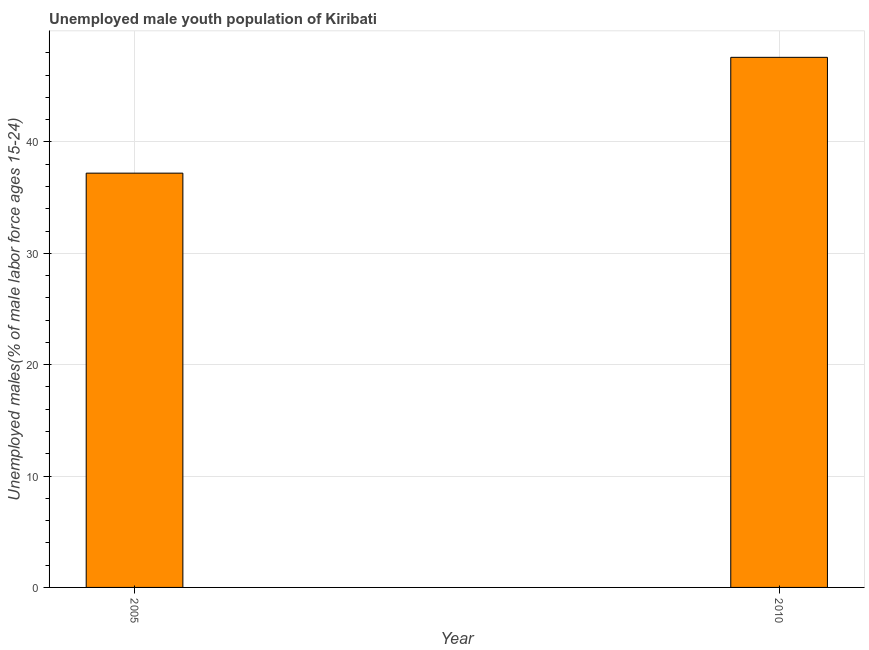Does the graph contain grids?
Your answer should be very brief. Yes. What is the title of the graph?
Provide a succinct answer. Unemployed male youth population of Kiribati. What is the label or title of the X-axis?
Give a very brief answer. Year. What is the label or title of the Y-axis?
Your answer should be very brief. Unemployed males(% of male labor force ages 15-24). What is the unemployed male youth in 2010?
Offer a terse response. 47.6. Across all years, what is the maximum unemployed male youth?
Your response must be concise. 47.6. Across all years, what is the minimum unemployed male youth?
Offer a very short reply. 37.2. In which year was the unemployed male youth maximum?
Provide a short and direct response. 2010. In which year was the unemployed male youth minimum?
Keep it short and to the point. 2005. What is the sum of the unemployed male youth?
Make the answer very short. 84.8. What is the average unemployed male youth per year?
Offer a very short reply. 42.4. What is the median unemployed male youth?
Provide a succinct answer. 42.4. Do a majority of the years between 2010 and 2005 (inclusive) have unemployed male youth greater than 26 %?
Your answer should be very brief. No. What is the ratio of the unemployed male youth in 2005 to that in 2010?
Offer a terse response. 0.78. Is the unemployed male youth in 2005 less than that in 2010?
Offer a very short reply. Yes. In how many years, is the unemployed male youth greater than the average unemployed male youth taken over all years?
Make the answer very short. 1. How many bars are there?
Provide a succinct answer. 2. Are all the bars in the graph horizontal?
Keep it short and to the point. No. Are the values on the major ticks of Y-axis written in scientific E-notation?
Make the answer very short. No. What is the Unemployed males(% of male labor force ages 15-24) of 2005?
Provide a succinct answer. 37.2. What is the Unemployed males(% of male labor force ages 15-24) in 2010?
Keep it short and to the point. 47.6. What is the difference between the Unemployed males(% of male labor force ages 15-24) in 2005 and 2010?
Your answer should be compact. -10.4. What is the ratio of the Unemployed males(% of male labor force ages 15-24) in 2005 to that in 2010?
Your answer should be very brief. 0.78. 